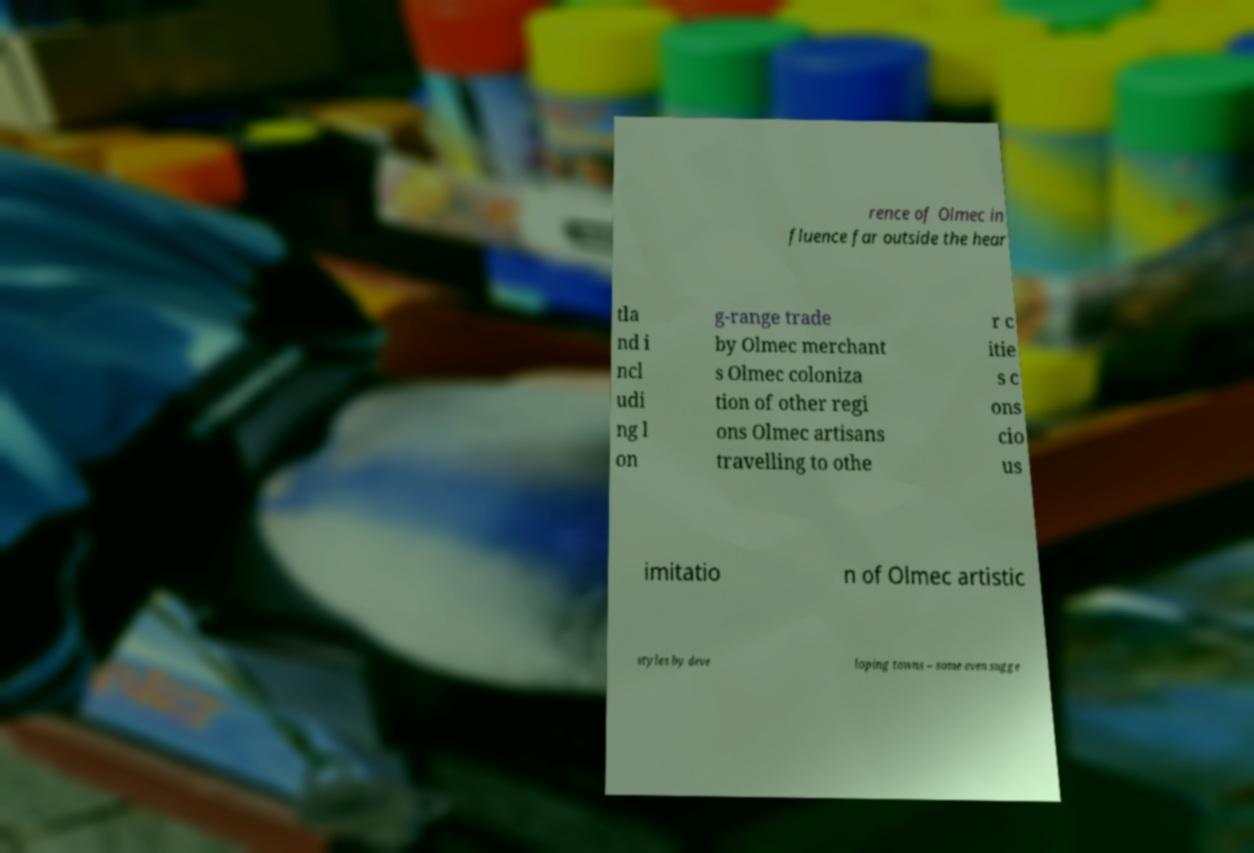Please identify and transcribe the text found in this image. rence of Olmec in fluence far outside the hear tla nd i ncl udi ng l on g-range trade by Olmec merchant s Olmec coloniza tion of other regi ons Olmec artisans travelling to othe r c itie s c ons cio us imitatio n of Olmec artistic styles by deve loping towns – some even sugge 